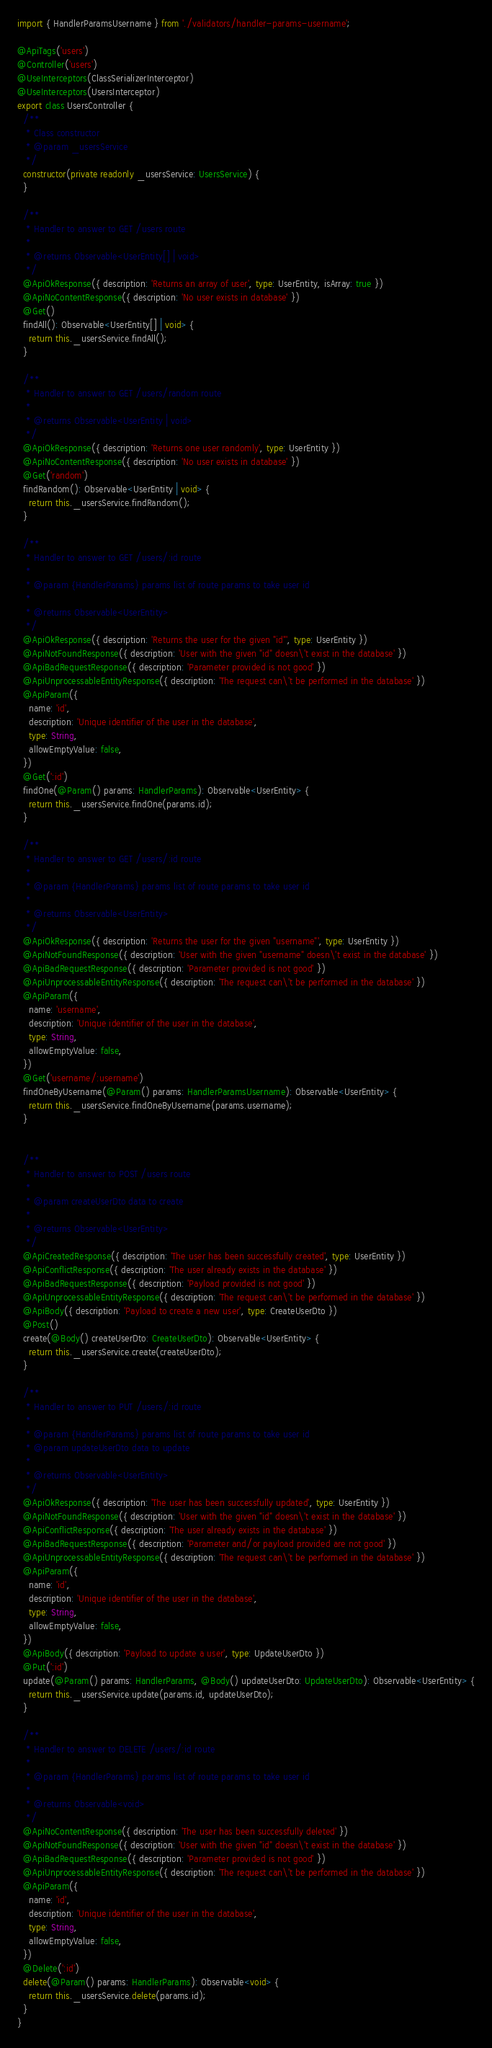<code> <loc_0><loc_0><loc_500><loc_500><_TypeScript_>import { HandlerParamsUsername } from './validators/handler-params-username';

@ApiTags('users')
@Controller('users')
@UseInterceptors(ClassSerializerInterceptor)
@UseInterceptors(UsersInterceptor)
export class UsersController {
  /**
   * Class constructor
   * @param _usersService
   */
  constructor(private readonly _usersService: UsersService) {
  }

  /**
   * Handler to answer to GET /users route
   *
   * @returns Observable<UserEntity[] | void>
   */
  @ApiOkResponse({ description: 'Returns an array of user', type: UserEntity, isArray: true })
  @ApiNoContentResponse({ description: 'No user exists in database' })
  @Get()
  findAll(): Observable<UserEntity[] | void> {
    return this._usersService.findAll();
  }

  /**
   * Handler to answer to GET /users/random route
   *
   * @returns Observable<UserEntity | void>
   */
  @ApiOkResponse({ description: 'Returns one user randomly', type: UserEntity })
  @ApiNoContentResponse({ description: 'No user exists in database' })
  @Get('random')
  findRandom(): Observable<UserEntity | void> {
    return this._usersService.findRandom();
  }

  /**
   * Handler to answer to GET /users/:id route
   *
   * @param {HandlerParams} params list of route params to take user id
   *
   * @returns Observable<UserEntity>
   */
  @ApiOkResponse({ description: 'Returns the user for the given "id"', type: UserEntity })
  @ApiNotFoundResponse({ description: 'User with the given "id" doesn\'t exist in the database' })
  @ApiBadRequestResponse({ description: 'Parameter provided is not good' })
  @ApiUnprocessableEntityResponse({ description: 'The request can\'t be performed in the database' })
  @ApiParam({
    name: 'id',
    description: 'Unique identifier of the user in the database',
    type: String,
    allowEmptyValue: false,
  })
  @Get(':id')
  findOne(@Param() params: HandlerParams): Observable<UserEntity> {
    return this._usersService.findOne(params.id);
  }

  /**
   * Handler to answer to GET /users/:id route
   *
   * @param {HandlerParams} params list of route params to take user id
   *
   * @returns Observable<UserEntity>
   */
  @ApiOkResponse({ description: 'Returns the user for the given "username"', type: UserEntity })
  @ApiNotFoundResponse({ description: 'User with the given "username" doesn\'t exist in the database' })
  @ApiBadRequestResponse({ description: 'Parameter provided is not good' })
  @ApiUnprocessableEntityResponse({ description: 'The request can\'t be performed in the database' })
  @ApiParam({
    name: 'username',
    description: 'Unique identifier of the user in the database',
    type: String,
    allowEmptyValue: false,
  })
  @Get('username/:username')
  findOneByUsername(@Param() params: HandlerParamsUsername): Observable<UserEntity> {
    return this._usersService.findOneByUsername(params.username);
  }


  /**
   * Handler to answer to POST /users route
   *
   * @param createUserDto data to create
   *
   * @returns Observable<UserEntity>
   */
  @ApiCreatedResponse({ description: 'The user has been successfully created', type: UserEntity })
  @ApiConflictResponse({ description: 'The user already exists in the database' })
  @ApiBadRequestResponse({ description: 'Payload provided is not good' })
  @ApiUnprocessableEntityResponse({ description: 'The request can\'t be performed in the database' })
  @ApiBody({ description: 'Payload to create a new user', type: CreateUserDto })
  @Post()
  create(@Body() createUserDto: CreateUserDto): Observable<UserEntity> {
    return this._usersService.create(createUserDto);
  }

  /**
   * Handler to answer to PUT /users/:id route
   *
   * @param {HandlerParams} params list of route params to take user id
   * @param updateUserDto data to update
   *
   * @returns Observable<UserEntity>
   */
  @ApiOkResponse({ description: 'The user has been successfully updated', type: UserEntity })
  @ApiNotFoundResponse({ description: 'User with the given "id" doesn\'t exist in the database' })
  @ApiConflictResponse({ description: 'The user already exists in the database' })
  @ApiBadRequestResponse({ description: 'Parameter and/or payload provided are not good' })
  @ApiUnprocessableEntityResponse({ description: 'The request can\'t be performed in the database' })
  @ApiParam({
    name: 'id',
    description: 'Unique identifier of the user in the database',
    type: String,
    allowEmptyValue: false,
  })
  @ApiBody({ description: 'Payload to update a user', type: UpdateUserDto })
  @Put(':id')
  update(@Param() params: HandlerParams, @Body() updateUserDto: UpdateUserDto): Observable<UserEntity> {
    return this._usersService.update(params.id, updateUserDto);
  }

  /**
   * Handler to answer to DELETE /users/:id route
   *
   * @param {HandlerParams} params list of route params to take user id
   *
   * @returns Observable<void>
   */
  @ApiNoContentResponse({ description: 'The user has been successfully deleted' })
  @ApiNotFoundResponse({ description: 'User with the given "id" doesn\'t exist in the database' })
  @ApiBadRequestResponse({ description: 'Parameter provided is not good' })
  @ApiUnprocessableEntityResponse({ description: 'The request can\'t be performed in the database' })
  @ApiParam({
    name: 'id',
    description: 'Unique identifier of the user in the database',
    type: String,
    allowEmptyValue: false,
  })
  @Delete(':id')
  delete(@Param() params: HandlerParams): Observable<void> {
    return this._usersService.delete(params.id);
  }
}
</code> 